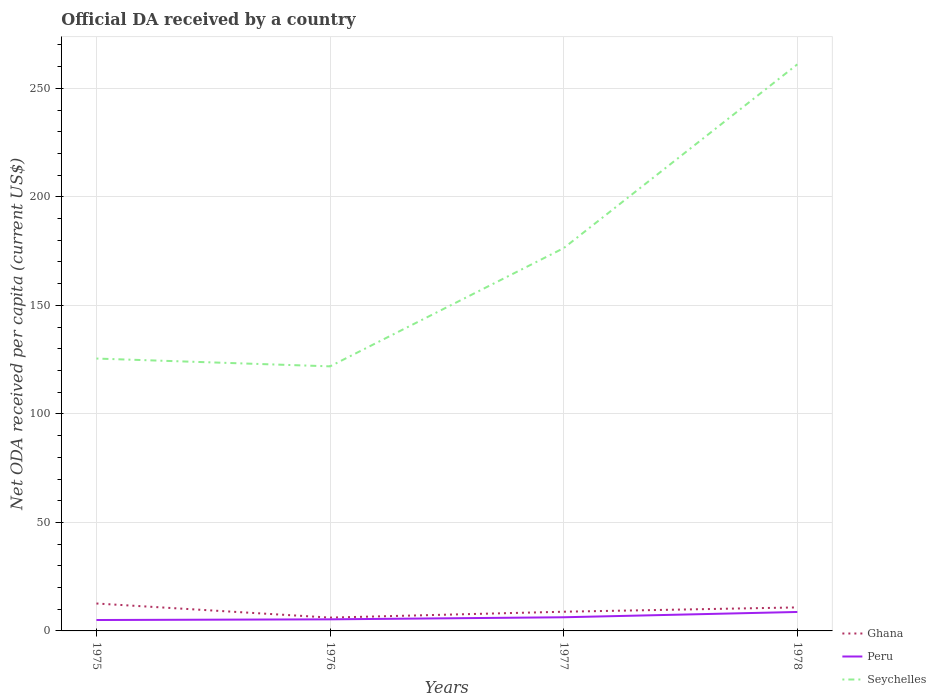Is the number of lines equal to the number of legend labels?
Give a very brief answer. Yes. Across all years, what is the maximum ODA received in in Ghana?
Make the answer very short. 6.14. In which year was the ODA received in in Seychelles maximum?
Your answer should be compact. 1976. What is the total ODA received in in Peru in the graph?
Give a very brief answer. -3.4. What is the difference between the highest and the second highest ODA received in in Ghana?
Offer a terse response. 6.49. How many lines are there?
Provide a short and direct response. 3. How many years are there in the graph?
Provide a succinct answer. 4. What is the difference between two consecutive major ticks on the Y-axis?
Ensure brevity in your answer.  50. Does the graph contain grids?
Your answer should be very brief. Yes. Where does the legend appear in the graph?
Your response must be concise. Bottom right. How are the legend labels stacked?
Keep it short and to the point. Vertical. What is the title of the graph?
Offer a very short reply. Official DA received by a country. What is the label or title of the X-axis?
Offer a very short reply. Years. What is the label or title of the Y-axis?
Provide a short and direct response. Net ODA received per capita (current US$). What is the Net ODA received per capita (current US$) in Ghana in 1975?
Provide a succinct answer. 12.63. What is the Net ODA received per capita (current US$) in Peru in 1975?
Your answer should be very brief. 5.03. What is the Net ODA received per capita (current US$) in Seychelles in 1975?
Offer a terse response. 125.5. What is the Net ODA received per capita (current US$) of Ghana in 1976?
Your answer should be very brief. 6.14. What is the Net ODA received per capita (current US$) of Peru in 1976?
Give a very brief answer. 5.34. What is the Net ODA received per capita (current US$) in Seychelles in 1976?
Keep it short and to the point. 121.9. What is the Net ODA received per capita (current US$) of Ghana in 1977?
Your response must be concise. 8.85. What is the Net ODA received per capita (current US$) in Peru in 1977?
Give a very brief answer. 6.29. What is the Net ODA received per capita (current US$) in Seychelles in 1977?
Provide a short and direct response. 176.38. What is the Net ODA received per capita (current US$) in Ghana in 1978?
Your answer should be compact. 10.83. What is the Net ODA received per capita (current US$) in Peru in 1978?
Your answer should be compact. 8.73. What is the Net ODA received per capita (current US$) in Seychelles in 1978?
Provide a succinct answer. 261.06. Across all years, what is the maximum Net ODA received per capita (current US$) in Ghana?
Your answer should be compact. 12.63. Across all years, what is the maximum Net ODA received per capita (current US$) of Peru?
Make the answer very short. 8.73. Across all years, what is the maximum Net ODA received per capita (current US$) in Seychelles?
Ensure brevity in your answer.  261.06. Across all years, what is the minimum Net ODA received per capita (current US$) of Ghana?
Provide a short and direct response. 6.14. Across all years, what is the minimum Net ODA received per capita (current US$) of Peru?
Give a very brief answer. 5.03. Across all years, what is the minimum Net ODA received per capita (current US$) in Seychelles?
Offer a terse response. 121.9. What is the total Net ODA received per capita (current US$) of Ghana in the graph?
Give a very brief answer. 38.46. What is the total Net ODA received per capita (current US$) in Peru in the graph?
Offer a terse response. 25.39. What is the total Net ODA received per capita (current US$) in Seychelles in the graph?
Your answer should be very brief. 684.84. What is the difference between the Net ODA received per capita (current US$) of Ghana in 1975 and that in 1976?
Provide a short and direct response. 6.49. What is the difference between the Net ODA received per capita (current US$) of Peru in 1975 and that in 1976?
Give a very brief answer. -0.31. What is the difference between the Net ODA received per capita (current US$) of Seychelles in 1975 and that in 1976?
Offer a terse response. 3.6. What is the difference between the Net ODA received per capita (current US$) in Ghana in 1975 and that in 1977?
Your answer should be very brief. 3.79. What is the difference between the Net ODA received per capita (current US$) in Peru in 1975 and that in 1977?
Offer a very short reply. -1.27. What is the difference between the Net ODA received per capita (current US$) of Seychelles in 1975 and that in 1977?
Give a very brief answer. -50.88. What is the difference between the Net ODA received per capita (current US$) of Ghana in 1975 and that in 1978?
Keep it short and to the point. 1.8. What is the difference between the Net ODA received per capita (current US$) in Peru in 1975 and that in 1978?
Offer a terse response. -3.7. What is the difference between the Net ODA received per capita (current US$) in Seychelles in 1975 and that in 1978?
Offer a terse response. -135.55. What is the difference between the Net ODA received per capita (current US$) of Ghana in 1976 and that in 1977?
Offer a very short reply. -2.71. What is the difference between the Net ODA received per capita (current US$) of Peru in 1976 and that in 1977?
Offer a terse response. -0.96. What is the difference between the Net ODA received per capita (current US$) of Seychelles in 1976 and that in 1977?
Your response must be concise. -54.48. What is the difference between the Net ODA received per capita (current US$) in Ghana in 1976 and that in 1978?
Provide a succinct answer. -4.69. What is the difference between the Net ODA received per capita (current US$) of Peru in 1976 and that in 1978?
Your response must be concise. -3.4. What is the difference between the Net ODA received per capita (current US$) of Seychelles in 1976 and that in 1978?
Your answer should be compact. -139.15. What is the difference between the Net ODA received per capita (current US$) of Ghana in 1977 and that in 1978?
Make the answer very short. -1.99. What is the difference between the Net ODA received per capita (current US$) of Peru in 1977 and that in 1978?
Your answer should be compact. -2.44. What is the difference between the Net ODA received per capita (current US$) of Seychelles in 1977 and that in 1978?
Your answer should be compact. -84.68. What is the difference between the Net ODA received per capita (current US$) of Ghana in 1975 and the Net ODA received per capita (current US$) of Peru in 1976?
Give a very brief answer. 7.3. What is the difference between the Net ODA received per capita (current US$) in Ghana in 1975 and the Net ODA received per capita (current US$) in Seychelles in 1976?
Your response must be concise. -109.27. What is the difference between the Net ODA received per capita (current US$) of Peru in 1975 and the Net ODA received per capita (current US$) of Seychelles in 1976?
Keep it short and to the point. -116.87. What is the difference between the Net ODA received per capita (current US$) of Ghana in 1975 and the Net ODA received per capita (current US$) of Peru in 1977?
Your response must be concise. 6.34. What is the difference between the Net ODA received per capita (current US$) of Ghana in 1975 and the Net ODA received per capita (current US$) of Seychelles in 1977?
Give a very brief answer. -163.75. What is the difference between the Net ODA received per capita (current US$) of Peru in 1975 and the Net ODA received per capita (current US$) of Seychelles in 1977?
Your answer should be very brief. -171.35. What is the difference between the Net ODA received per capita (current US$) in Ghana in 1975 and the Net ODA received per capita (current US$) in Peru in 1978?
Provide a short and direct response. 3.9. What is the difference between the Net ODA received per capita (current US$) in Ghana in 1975 and the Net ODA received per capita (current US$) in Seychelles in 1978?
Give a very brief answer. -248.42. What is the difference between the Net ODA received per capita (current US$) in Peru in 1975 and the Net ODA received per capita (current US$) in Seychelles in 1978?
Offer a very short reply. -256.03. What is the difference between the Net ODA received per capita (current US$) of Ghana in 1976 and the Net ODA received per capita (current US$) of Peru in 1977?
Your response must be concise. -0.15. What is the difference between the Net ODA received per capita (current US$) in Ghana in 1976 and the Net ODA received per capita (current US$) in Seychelles in 1977?
Give a very brief answer. -170.24. What is the difference between the Net ODA received per capita (current US$) in Peru in 1976 and the Net ODA received per capita (current US$) in Seychelles in 1977?
Ensure brevity in your answer.  -171.04. What is the difference between the Net ODA received per capita (current US$) of Ghana in 1976 and the Net ODA received per capita (current US$) of Peru in 1978?
Your response must be concise. -2.59. What is the difference between the Net ODA received per capita (current US$) of Ghana in 1976 and the Net ODA received per capita (current US$) of Seychelles in 1978?
Make the answer very short. -254.92. What is the difference between the Net ODA received per capita (current US$) in Peru in 1976 and the Net ODA received per capita (current US$) in Seychelles in 1978?
Keep it short and to the point. -255.72. What is the difference between the Net ODA received per capita (current US$) of Ghana in 1977 and the Net ODA received per capita (current US$) of Peru in 1978?
Provide a short and direct response. 0.12. What is the difference between the Net ODA received per capita (current US$) in Ghana in 1977 and the Net ODA received per capita (current US$) in Seychelles in 1978?
Your answer should be very brief. -252.21. What is the difference between the Net ODA received per capita (current US$) in Peru in 1977 and the Net ODA received per capita (current US$) in Seychelles in 1978?
Keep it short and to the point. -254.76. What is the average Net ODA received per capita (current US$) of Ghana per year?
Keep it short and to the point. 9.61. What is the average Net ODA received per capita (current US$) in Peru per year?
Give a very brief answer. 6.35. What is the average Net ODA received per capita (current US$) in Seychelles per year?
Provide a succinct answer. 171.21. In the year 1975, what is the difference between the Net ODA received per capita (current US$) in Ghana and Net ODA received per capita (current US$) in Peru?
Offer a very short reply. 7.61. In the year 1975, what is the difference between the Net ODA received per capita (current US$) of Ghana and Net ODA received per capita (current US$) of Seychelles?
Your response must be concise. -112.87. In the year 1975, what is the difference between the Net ODA received per capita (current US$) of Peru and Net ODA received per capita (current US$) of Seychelles?
Offer a terse response. -120.48. In the year 1976, what is the difference between the Net ODA received per capita (current US$) in Ghana and Net ODA received per capita (current US$) in Peru?
Your answer should be very brief. 0.8. In the year 1976, what is the difference between the Net ODA received per capita (current US$) of Ghana and Net ODA received per capita (current US$) of Seychelles?
Your answer should be compact. -115.76. In the year 1976, what is the difference between the Net ODA received per capita (current US$) in Peru and Net ODA received per capita (current US$) in Seychelles?
Provide a succinct answer. -116.57. In the year 1977, what is the difference between the Net ODA received per capita (current US$) in Ghana and Net ODA received per capita (current US$) in Peru?
Your response must be concise. 2.56. In the year 1977, what is the difference between the Net ODA received per capita (current US$) in Ghana and Net ODA received per capita (current US$) in Seychelles?
Keep it short and to the point. -167.53. In the year 1977, what is the difference between the Net ODA received per capita (current US$) in Peru and Net ODA received per capita (current US$) in Seychelles?
Offer a terse response. -170.09. In the year 1978, what is the difference between the Net ODA received per capita (current US$) of Ghana and Net ODA received per capita (current US$) of Peru?
Your answer should be compact. 2.1. In the year 1978, what is the difference between the Net ODA received per capita (current US$) in Ghana and Net ODA received per capita (current US$) in Seychelles?
Your answer should be compact. -250.22. In the year 1978, what is the difference between the Net ODA received per capita (current US$) of Peru and Net ODA received per capita (current US$) of Seychelles?
Your answer should be compact. -252.32. What is the ratio of the Net ODA received per capita (current US$) of Ghana in 1975 to that in 1976?
Give a very brief answer. 2.06. What is the ratio of the Net ODA received per capita (current US$) in Peru in 1975 to that in 1976?
Provide a succinct answer. 0.94. What is the ratio of the Net ODA received per capita (current US$) in Seychelles in 1975 to that in 1976?
Your answer should be compact. 1.03. What is the ratio of the Net ODA received per capita (current US$) in Ghana in 1975 to that in 1977?
Provide a short and direct response. 1.43. What is the ratio of the Net ODA received per capita (current US$) in Peru in 1975 to that in 1977?
Make the answer very short. 0.8. What is the ratio of the Net ODA received per capita (current US$) of Seychelles in 1975 to that in 1977?
Your response must be concise. 0.71. What is the ratio of the Net ODA received per capita (current US$) of Ghana in 1975 to that in 1978?
Your answer should be compact. 1.17. What is the ratio of the Net ODA received per capita (current US$) of Peru in 1975 to that in 1978?
Ensure brevity in your answer.  0.58. What is the ratio of the Net ODA received per capita (current US$) of Seychelles in 1975 to that in 1978?
Keep it short and to the point. 0.48. What is the ratio of the Net ODA received per capita (current US$) of Ghana in 1976 to that in 1977?
Provide a succinct answer. 0.69. What is the ratio of the Net ODA received per capita (current US$) of Peru in 1976 to that in 1977?
Offer a very short reply. 0.85. What is the ratio of the Net ODA received per capita (current US$) of Seychelles in 1976 to that in 1977?
Your response must be concise. 0.69. What is the ratio of the Net ODA received per capita (current US$) of Ghana in 1976 to that in 1978?
Offer a very short reply. 0.57. What is the ratio of the Net ODA received per capita (current US$) of Peru in 1976 to that in 1978?
Your answer should be compact. 0.61. What is the ratio of the Net ODA received per capita (current US$) of Seychelles in 1976 to that in 1978?
Provide a succinct answer. 0.47. What is the ratio of the Net ODA received per capita (current US$) of Ghana in 1977 to that in 1978?
Your answer should be compact. 0.82. What is the ratio of the Net ODA received per capita (current US$) of Peru in 1977 to that in 1978?
Provide a succinct answer. 0.72. What is the ratio of the Net ODA received per capita (current US$) in Seychelles in 1977 to that in 1978?
Your answer should be compact. 0.68. What is the difference between the highest and the second highest Net ODA received per capita (current US$) of Ghana?
Provide a succinct answer. 1.8. What is the difference between the highest and the second highest Net ODA received per capita (current US$) of Peru?
Your answer should be very brief. 2.44. What is the difference between the highest and the second highest Net ODA received per capita (current US$) of Seychelles?
Make the answer very short. 84.68. What is the difference between the highest and the lowest Net ODA received per capita (current US$) of Ghana?
Make the answer very short. 6.49. What is the difference between the highest and the lowest Net ODA received per capita (current US$) in Peru?
Provide a succinct answer. 3.7. What is the difference between the highest and the lowest Net ODA received per capita (current US$) of Seychelles?
Give a very brief answer. 139.15. 